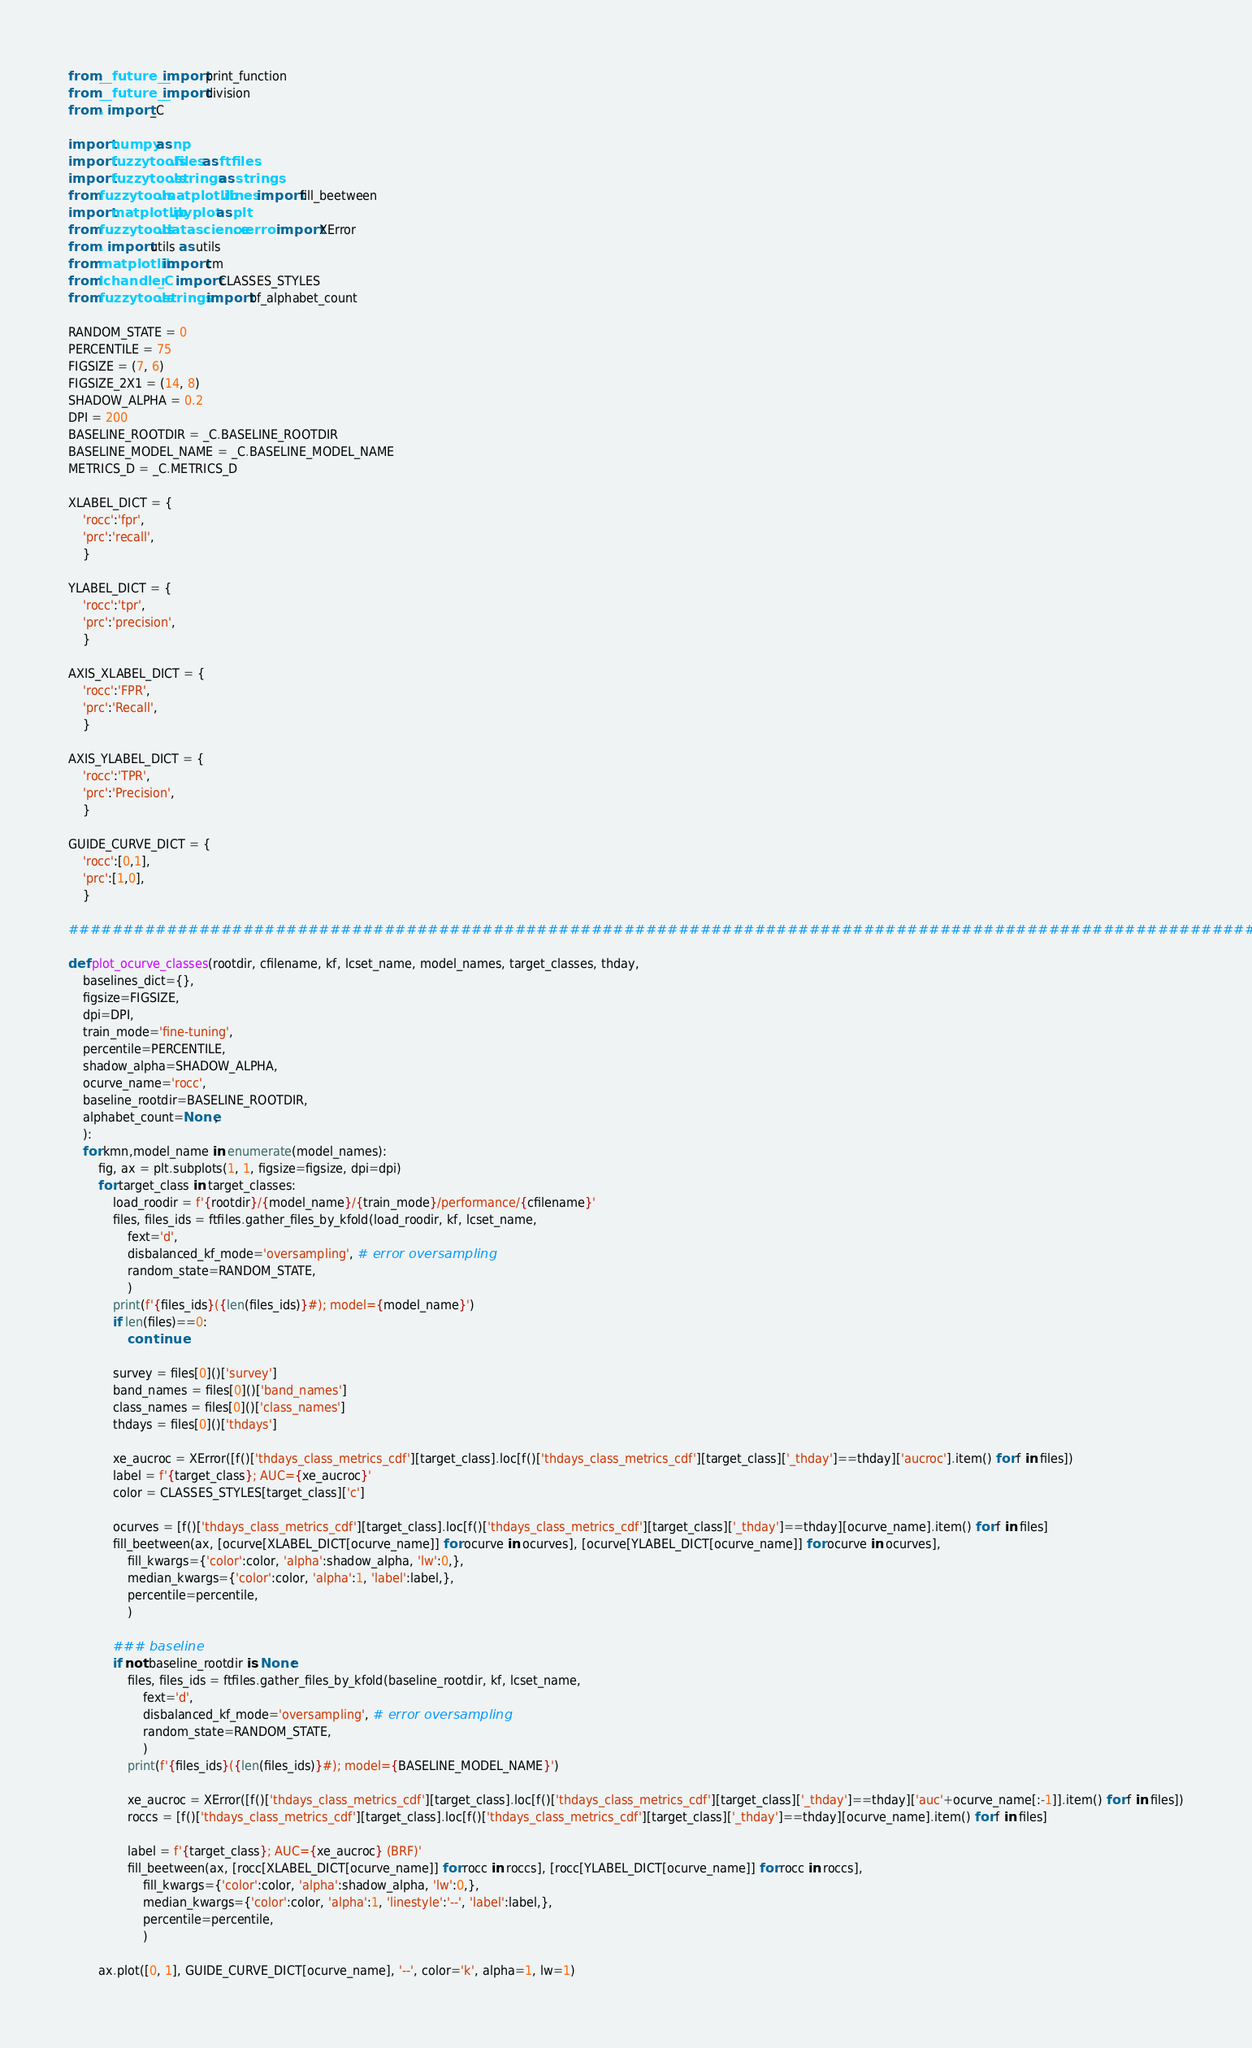Convert code to text. <code><loc_0><loc_0><loc_500><loc_500><_Python_>from __future__ import print_function
from __future__ import division
from . import _C

import numpy as np
import fuzzytools.files as ftfiles
import fuzzytools.strings as strings
from fuzzytools.matplotlib.lines import fill_beetween
import matplotlib.pyplot as plt
from fuzzytools.datascience.xerror import XError
from . import utils as utils
from matplotlib import cm
from lchandler._C import CLASSES_STYLES
from fuzzytools.strings import bf_alphabet_count

RANDOM_STATE = 0
PERCENTILE = 75
FIGSIZE = (7, 6)
FIGSIZE_2X1 = (14, 8)
SHADOW_ALPHA = 0.2
DPI = 200
BASELINE_ROOTDIR = _C.BASELINE_ROOTDIR
BASELINE_MODEL_NAME = _C.BASELINE_MODEL_NAME
METRICS_D = _C.METRICS_D

XLABEL_DICT = {
	'rocc':'fpr',
	'prc':'recall',
	}

YLABEL_DICT = {
	'rocc':'tpr',
	'prc':'precision',
	}

AXIS_XLABEL_DICT = {
	'rocc':'FPR',
	'prc':'Recall',
	}

AXIS_YLABEL_DICT = {
	'rocc':'TPR',
	'prc':'Precision',
	}

GUIDE_CURVE_DICT = {
	'rocc':[0,1],
	'prc':[1,0],
	}

################################################################################################################

def plot_ocurve_classes(rootdir, cfilename, kf, lcset_name, model_names, target_classes, thday,
	baselines_dict={},
	figsize=FIGSIZE,
	dpi=DPI,
	train_mode='fine-tuning',
	percentile=PERCENTILE,
	shadow_alpha=SHADOW_ALPHA,
	ocurve_name='rocc',
	baseline_rootdir=BASELINE_ROOTDIR,
	alphabet_count=None,
	):
	for kmn,model_name in enumerate(model_names):
		fig, ax = plt.subplots(1, 1, figsize=figsize, dpi=dpi)
		for target_class in target_classes:
			load_roodir = f'{rootdir}/{model_name}/{train_mode}/performance/{cfilename}'
			files, files_ids = ftfiles.gather_files_by_kfold(load_roodir, kf, lcset_name,
				fext='d',
				disbalanced_kf_mode='oversampling', # error oversampling
				random_state=RANDOM_STATE,
				)
			print(f'{files_ids}({len(files_ids)}#); model={model_name}')
			if len(files)==0:
				continue

			survey = files[0]()['survey']
			band_names = files[0]()['band_names']
			class_names = files[0]()['class_names']
			thdays = files[0]()['thdays']

			xe_aucroc = XError([f()['thdays_class_metrics_cdf'][target_class].loc[f()['thdays_class_metrics_cdf'][target_class]['_thday']==thday]['aucroc'].item() for f in files])
			label = f'{target_class}; AUC={xe_aucroc}'
			color = CLASSES_STYLES[target_class]['c']

			ocurves = [f()['thdays_class_metrics_cdf'][target_class].loc[f()['thdays_class_metrics_cdf'][target_class]['_thday']==thday][ocurve_name].item() for f in files]
			fill_beetween(ax, [ocurve[XLABEL_DICT[ocurve_name]] for ocurve in ocurves], [ocurve[YLABEL_DICT[ocurve_name]] for ocurve in ocurves],
				fill_kwargs={'color':color, 'alpha':shadow_alpha, 'lw':0,},
				median_kwargs={'color':color, 'alpha':1, 'label':label,},
				percentile=percentile,
				)

			### baseline
			if not baseline_rootdir is None:
				files, files_ids = ftfiles.gather_files_by_kfold(baseline_rootdir, kf, lcset_name,
					fext='d',
					disbalanced_kf_mode='oversampling', # error oversampling
					random_state=RANDOM_STATE,
					)
				print(f'{files_ids}({len(files_ids)}#); model={BASELINE_MODEL_NAME}')
				
				xe_aucroc = XError([f()['thdays_class_metrics_cdf'][target_class].loc[f()['thdays_class_metrics_cdf'][target_class]['_thday']==thday]['auc'+ocurve_name[:-1]].item() for f in files])
				roccs = [f()['thdays_class_metrics_cdf'][target_class].loc[f()['thdays_class_metrics_cdf'][target_class]['_thday']==thday][ocurve_name].item() for f in files]

				label = f'{target_class}; AUC={xe_aucroc} (BRF)'
				fill_beetween(ax, [rocc[XLABEL_DICT[ocurve_name]] for rocc in roccs], [rocc[YLABEL_DICT[ocurve_name]] for rocc in roccs],
					fill_kwargs={'color':color, 'alpha':shadow_alpha, 'lw':0,},
					median_kwargs={'color':color, 'alpha':1, 'linestyle':'--', 'label':label,},
					percentile=percentile,
					)

		ax.plot([0, 1], GUIDE_CURVE_DICT[ocurve_name], '--', color='k', alpha=1, lw=1)</code> 